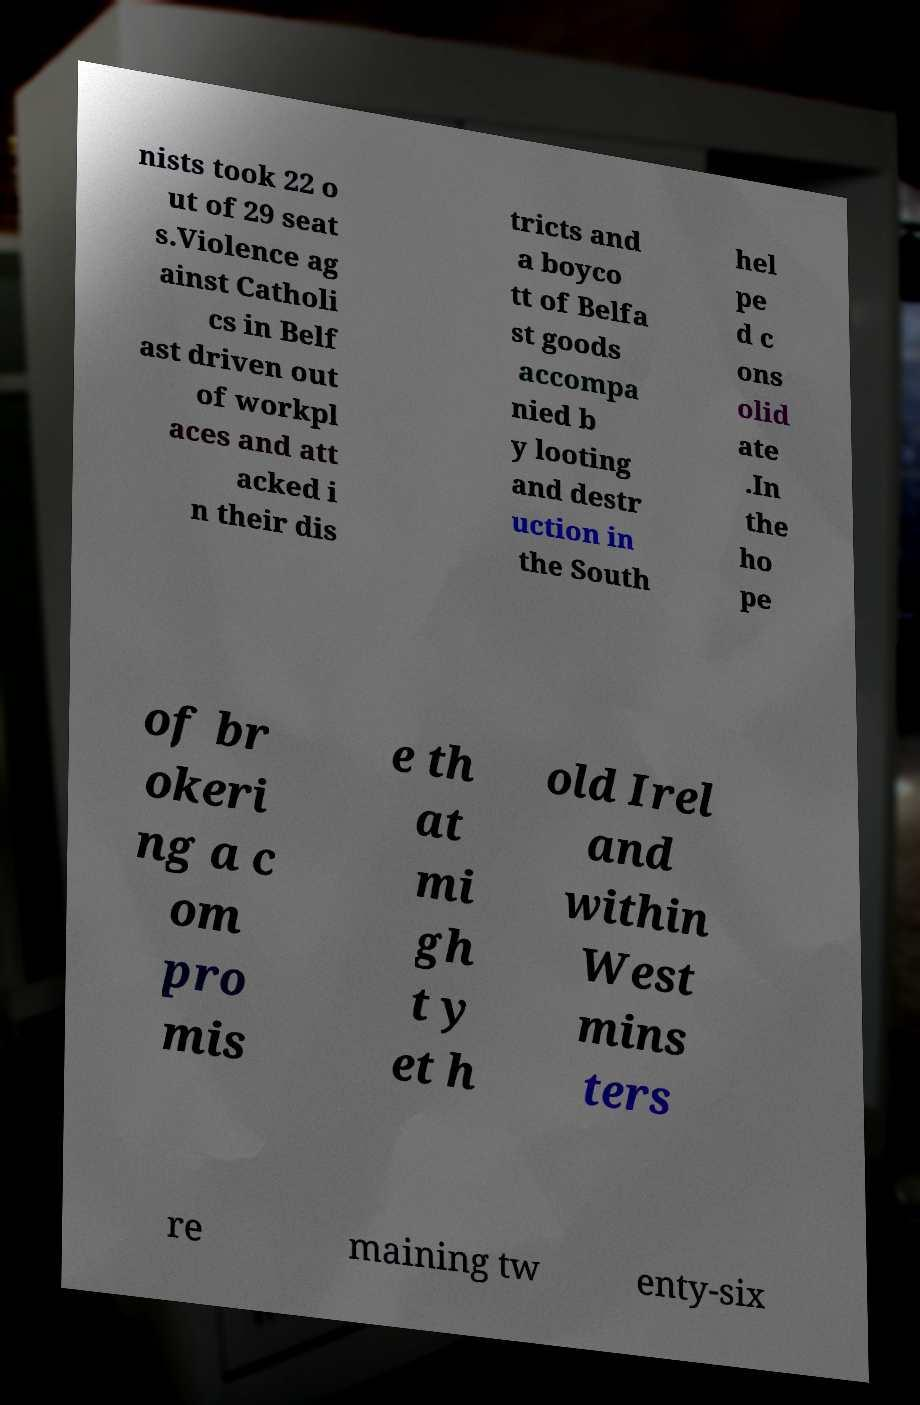Please read and relay the text visible in this image. What does it say? nists took 22 o ut of 29 seat s.Violence ag ainst Catholi cs in Belf ast driven out of workpl aces and att acked i n their dis tricts and a boyco tt of Belfa st goods accompa nied b y looting and destr uction in the South hel pe d c ons olid ate .In the ho pe of br okeri ng a c om pro mis e th at mi gh t y et h old Irel and within West mins ters re maining tw enty-six 